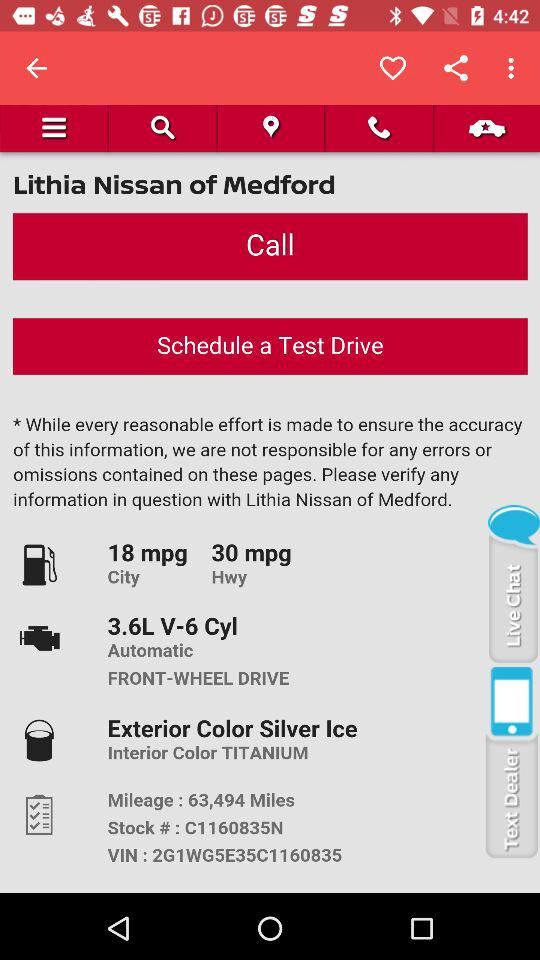How many more miles does the car get on the highway than in the city?
Answer the question using a single word or phrase. 12 